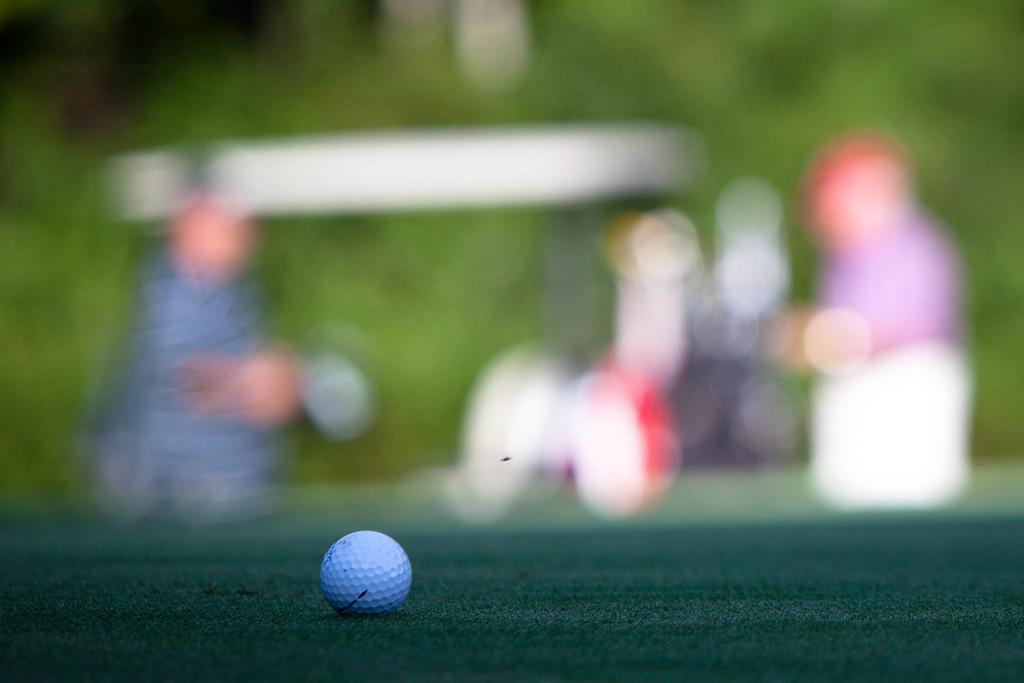What object is the main focus of the image? There is a golf ball in the image. Can you describe the background of the image? The background of the image appears blurry. How many times does the golfer rub the fog off the golf ball in the image? There is no golfer or fog present in the image, so it is not possible to answer that question. 